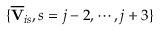<formula> <loc_0><loc_0><loc_500><loc_500>\{ \overline { V } _ { i s } , s = j - 2 , \cdots , j + 3 \}</formula> 